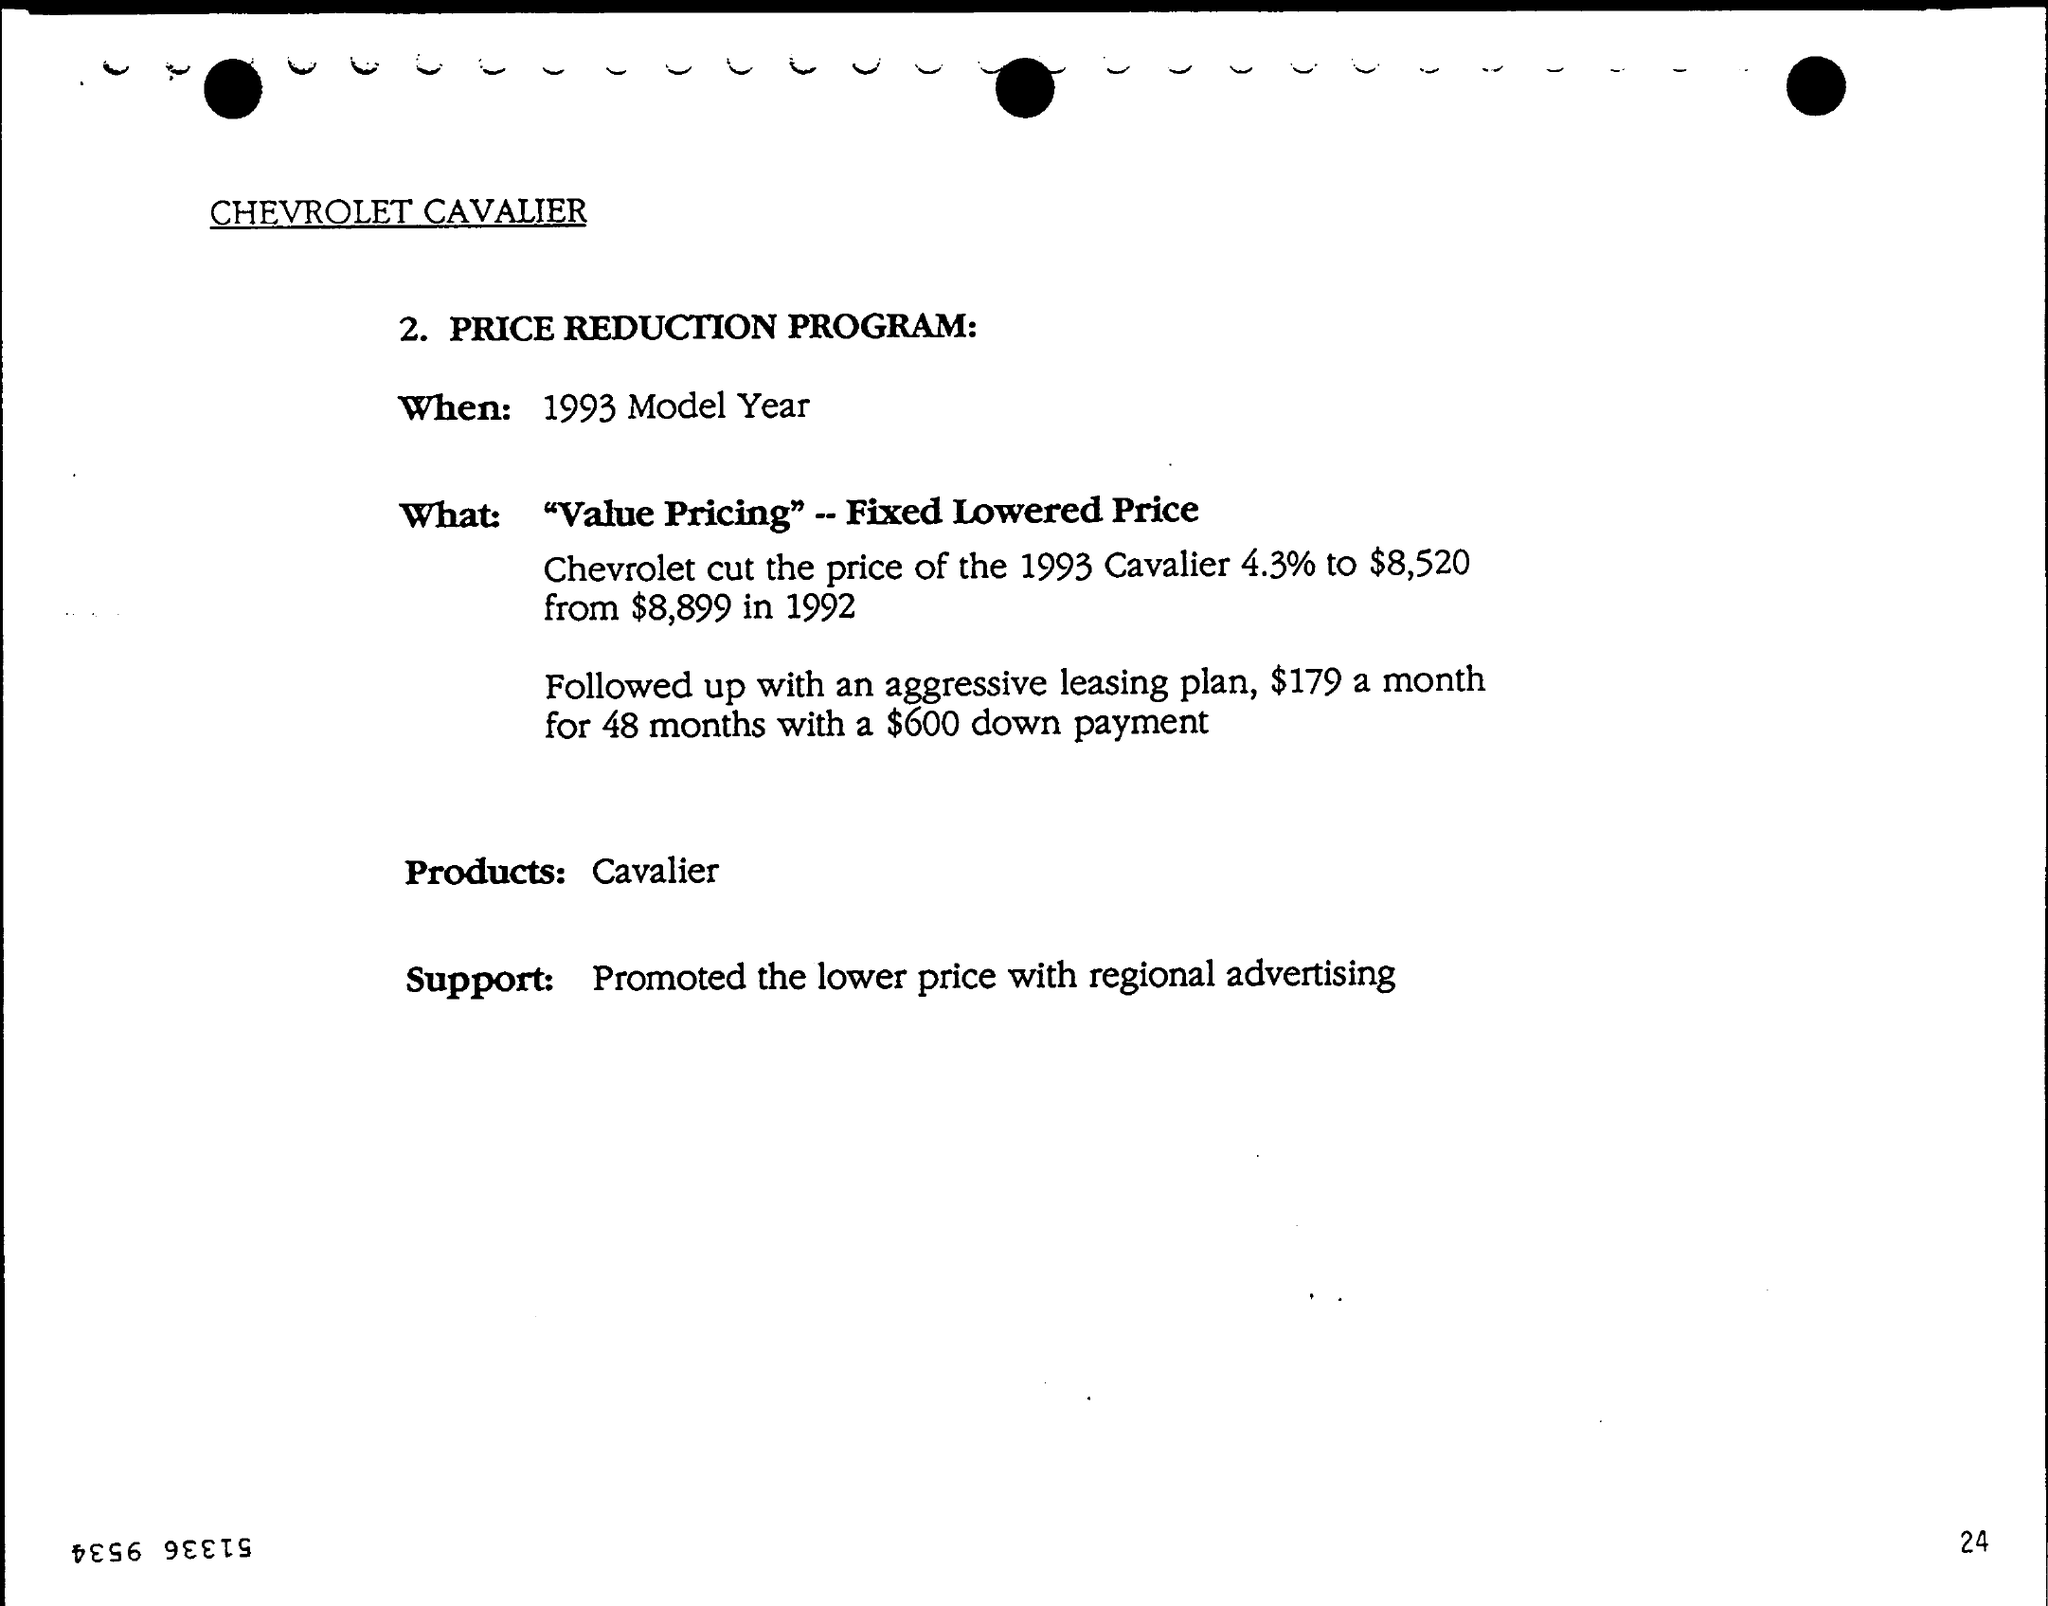Which brand is mentioned?
Provide a short and direct response. CHEVROLET CAVALIER. When is the PRICE REDUCTION PROGRAM?
Your answer should be very brief. 1993 Model Year. What was the support?
Ensure brevity in your answer.  Promoted the lower price with regional advertising. 